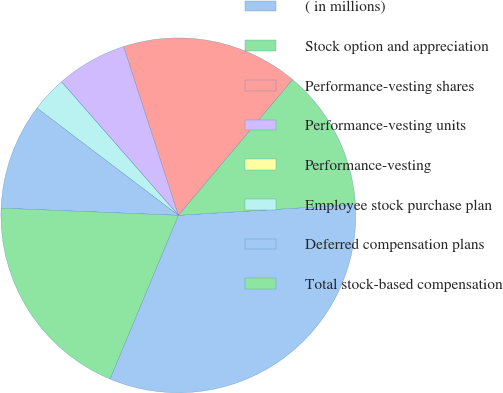Convert chart to OTSL. <chart><loc_0><loc_0><loc_500><loc_500><pie_chart><fcel>( in millions)<fcel>Stock option and appreciation<fcel>Performance-vesting shares<fcel>Performance-vesting units<fcel>Performance-vesting<fcel>Employee stock purchase plan<fcel>Deferred compensation plans<fcel>Total stock-based compensation<nl><fcel>32.26%<fcel>12.9%<fcel>16.13%<fcel>6.45%<fcel>0.0%<fcel>3.23%<fcel>9.68%<fcel>19.35%<nl></chart> 